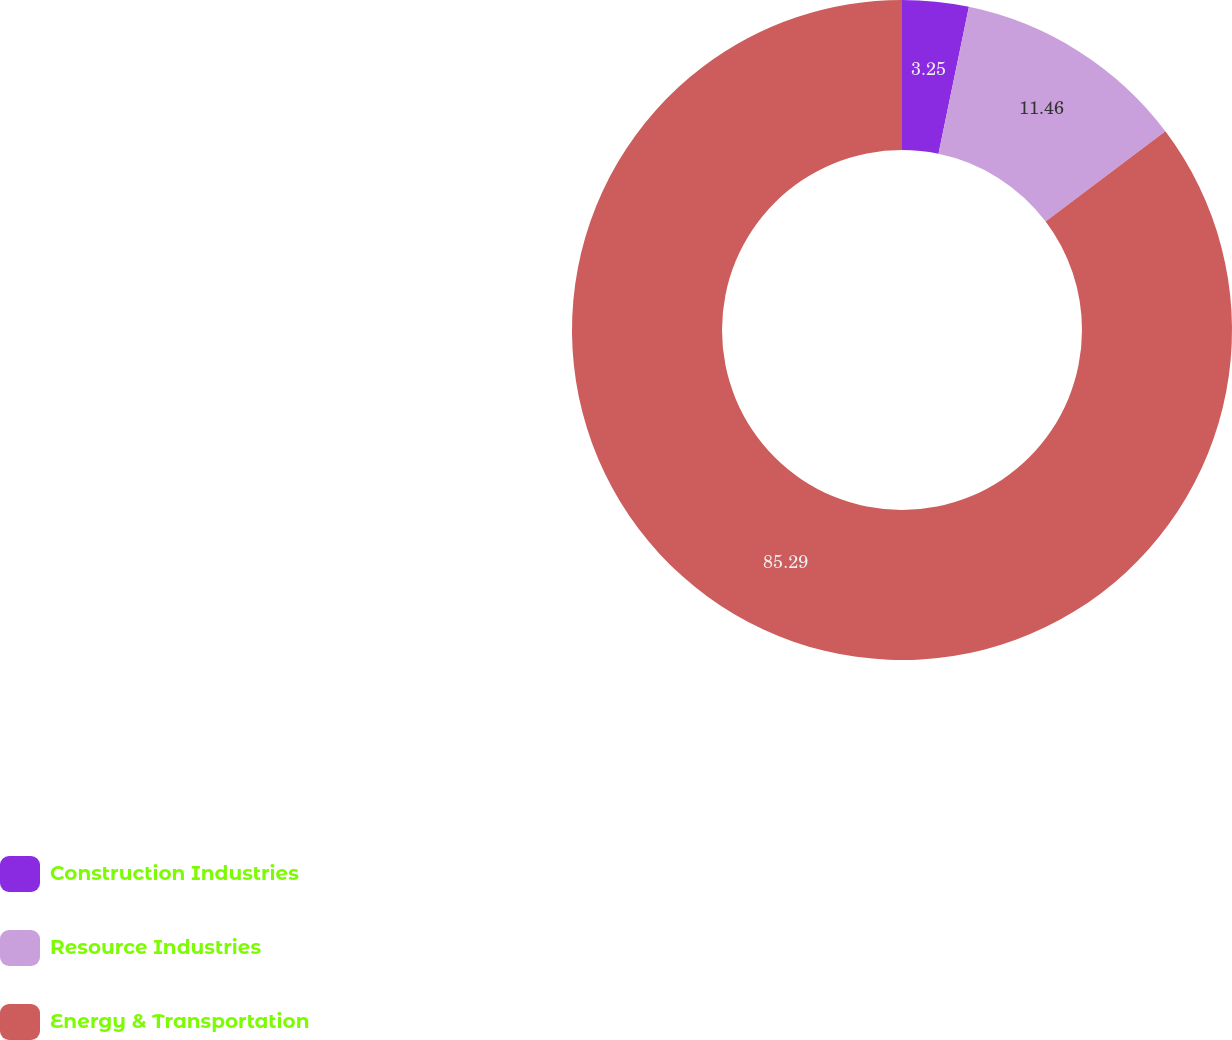Convert chart. <chart><loc_0><loc_0><loc_500><loc_500><pie_chart><fcel>Construction Industries<fcel>Resource Industries<fcel>Energy & Transportation<nl><fcel>3.25%<fcel>11.46%<fcel>85.29%<nl></chart> 